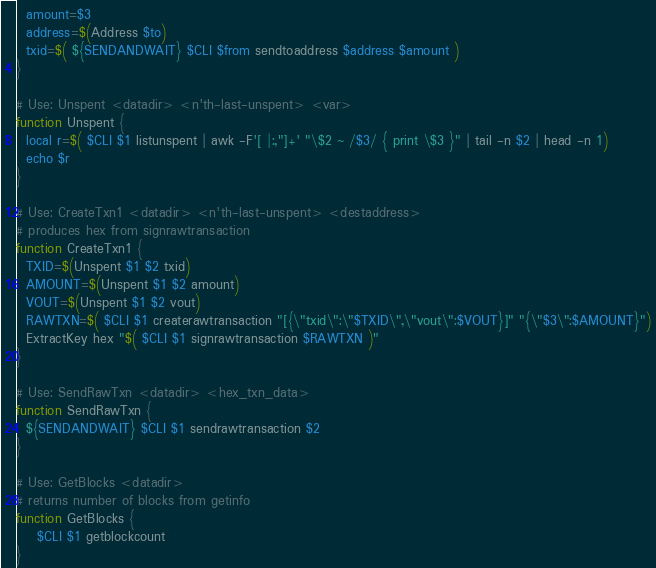Convert code to text. <code><loc_0><loc_0><loc_500><loc_500><_Bash_>  amount=$3
  address=$(Address $to)
  txid=$( ${SENDANDWAIT} $CLI $from sendtoaddress $address $amount )
}

# Use: Unspent <datadir> <n'th-last-unspent> <var>
function Unspent {
  local r=$( $CLI $1 listunspent | awk -F'[ |:,"]+' "\$2 ~ /$3/ { print \$3 }" | tail -n $2 | head -n 1)
  echo $r
}

# Use: CreateTxn1 <datadir> <n'th-last-unspent> <destaddress>
# produces hex from signrawtransaction
function CreateTxn1 {
  TXID=$(Unspent $1 $2 txid)
  AMOUNT=$(Unspent $1 $2 amount)
  VOUT=$(Unspent $1 $2 vout)
  RAWTXN=$( $CLI $1 createrawtransaction "[{\"txid\":\"$TXID\",\"vout\":$VOUT}]" "{\"$3\":$AMOUNT}")
  ExtractKey hex "$( $CLI $1 signrawtransaction $RAWTXN )"
}

# Use: SendRawTxn <datadir> <hex_txn_data>
function SendRawTxn {
  ${SENDANDWAIT} $CLI $1 sendrawtransaction $2
}

# Use: GetBlocks <datadir>
# returns number of blocks from getinfo
function GetBlocks {
    $CLI $1 getblockcount
}
</code> 